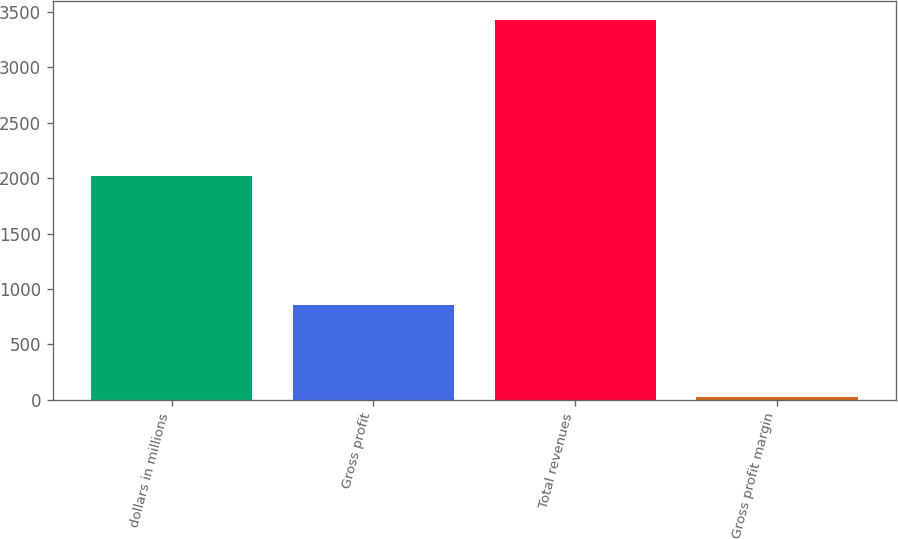<chart> <loc_0><loc_0><loc_500><loc_500><bar_chart><fcel>dollars in millions<fcel>Gross profit<fcel>Total revenues<fcel>Gross profit margin<nl><fcel>2015<fcel>857.5<fcel>3422.2<fcel>25.1<nl></chart> 